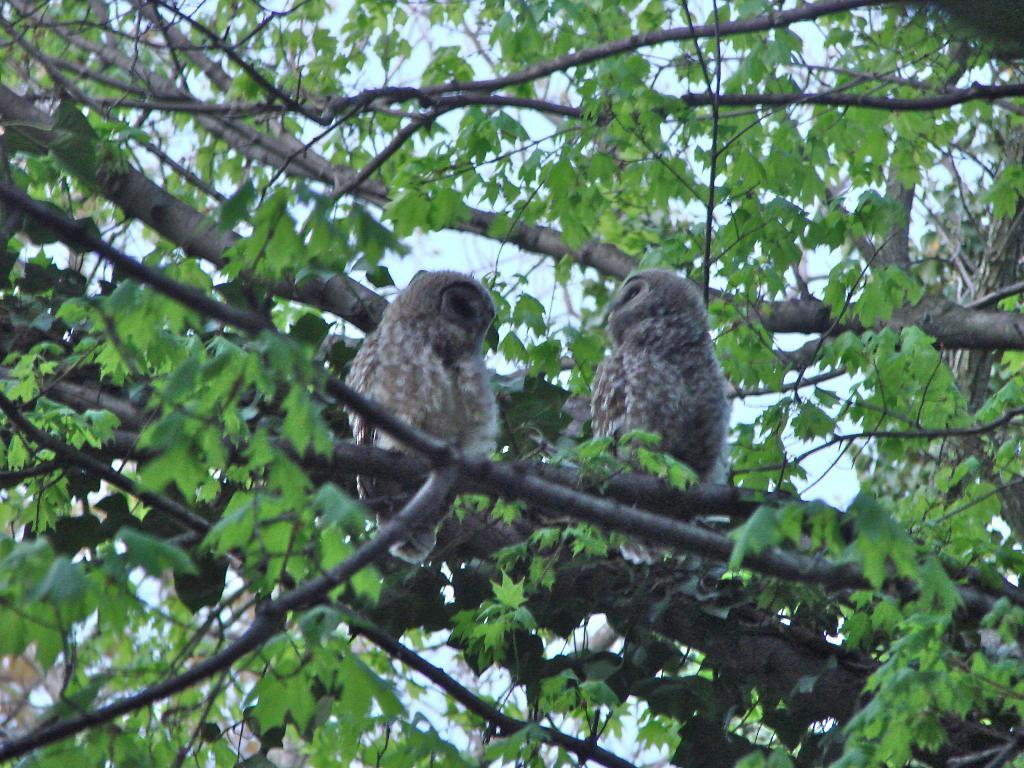How many owls are in the image? There are two owls in the image. Where are the owls located? The owls are on the stem of a tree. What type of vegetation is present in the image? There are green leaves in the image. What is visible at the top of the image? The sky is visible at the top of the image. What type of soda is being advertised by the flag in the image? There is no flag or soda present in the image; it features two owls on the stem of a tree with green leaves and a visible sky. 